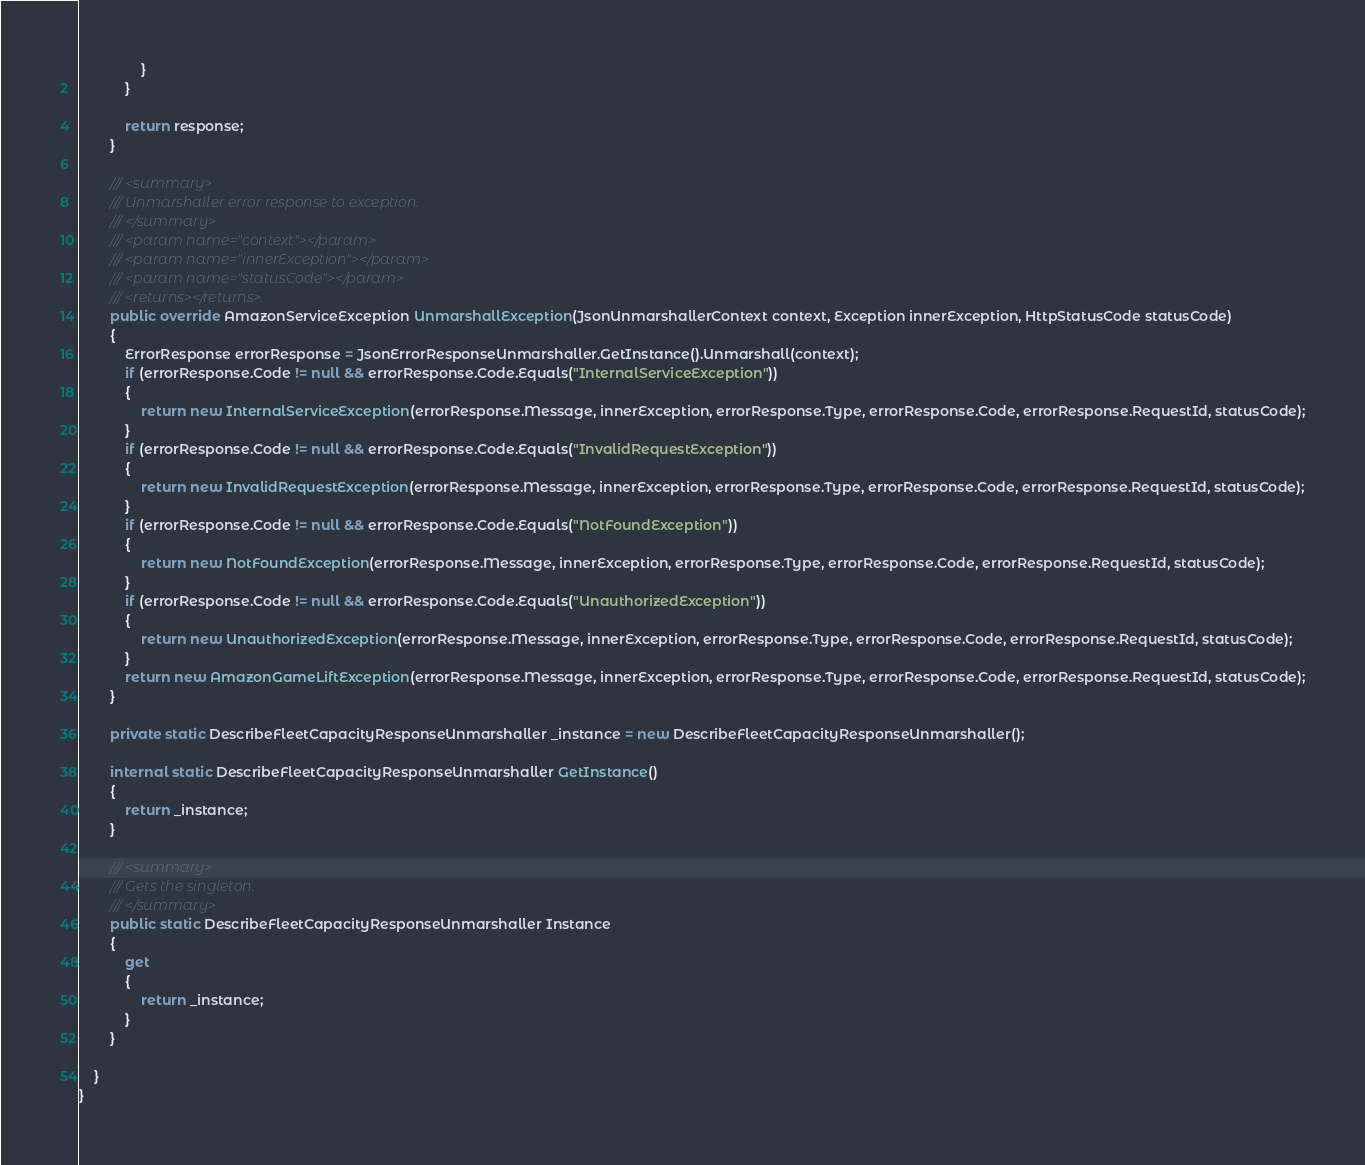Convert code to text. <code><loc_0><loc_0><loc_500><loc_500><_C#_>                }
            }

            return response;
        }

        /// <summary>
        /// Unmarshaller error response to exception.
        /// </summary>  
        /// <param name="context"></param>
        /// <param name="innerException"></param>
        /// <param name="statusCode"></param>
        /// <returns></returns>
        public override AmazonServiceException UnmarshallException(JsonUnmarshallerContext context, Exception innerException, HttpStatusCode statusCode)
        {
            ErrorResponse errorResponse = JsonErrorResponseUnmarshaller.GetInstance().Unmarshall(context);
            if (errorResponse.Code != null && errorResponse.Code.Equals("InternalServiceException"))
            {
                return new InternalServiceException(errorResponse.Message, innerException, errorResponse.Type, errorResponse.Code, errorResponse.RequestId, statusCode);
            }
            if (errorResponse.Code != null && errorResponse.Code.Equals("InvalidRequestException"))
            {
                return new InvalidRequestException(errorResponse.Message, innerException, errorResponse.Type, errorResponse.Code, errorResponse.RequestId, statusCode);
            }
            if (errorResponse.Code != null && errorResponse.Code.Equals("NotFoundException"))
            {
                return new NotFoundException(errorResponse.Message, innerException, errorResponse.Type, errorResponse.Code, errorResponse.RequestId, statusCode);
            }
            if (errorResponse.Code != null && errorResponse.Code.Equals("UnauthorizedException"))
            {
                return new UnauthorizedException(errorResponse.Message, innerException, errorResponse.Type, errorResponse.Code, errorResponse.RequestId, statusCode);
            }
            return new AmazonGameLiftException(errorResponse.Message, innerException, errorResponse.Type, errorResponse.Code, errorResponse.RequestId, statusCode);
        }

        private static DescribeFleetCapacityResponseUnmarshaller _instance = new DescribeFleetCapacityResponseUnmarshaller();        

        internal static DescribeFleetCapacityResponseUnmarshaller GetInstance()
        {
            return _instance;
        }

        /// <summary>
        /// Gets the singleton.
        /// </summary>  
        public static DescribeFleetCapacityResponseUnmarshaller Instance
        {
            get
            {
                return _instance;
            }
        }

    }
}</code> 